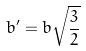Convert formula to latex. <formula><loc_0><loc_0><loc_500><loc_500>b ^ { \prime } = b \sqrt { \frac { 3 } { 2 } }</formula> 